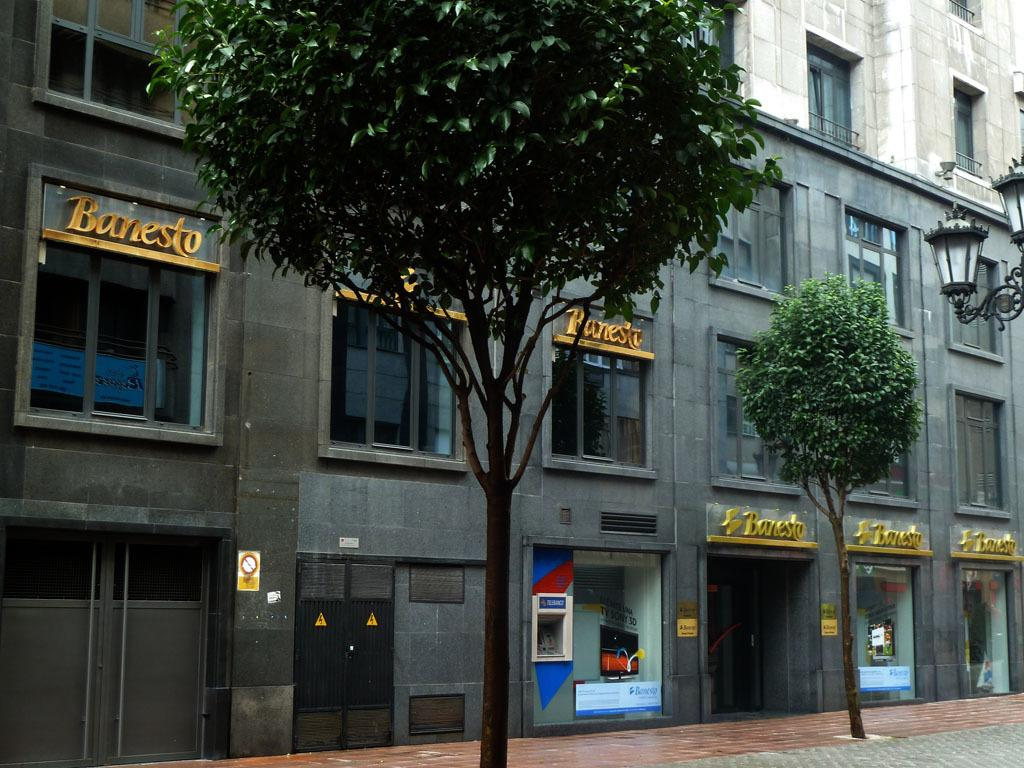What structure can be seen in the image? There is a building in the image. What is located in front of the building? There is a plant and a tree in front of the building. Where are the lights positioned in relation to the building? The lights are to the right of the building. What type of curtain can be seen hanging from the tree in the image? There is no curtain present in the image; there is only a tree and a plant in front of the building. 